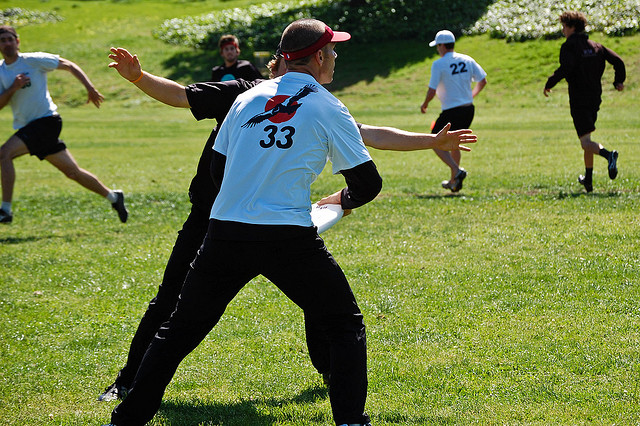Read all the text in this image. 33 22 